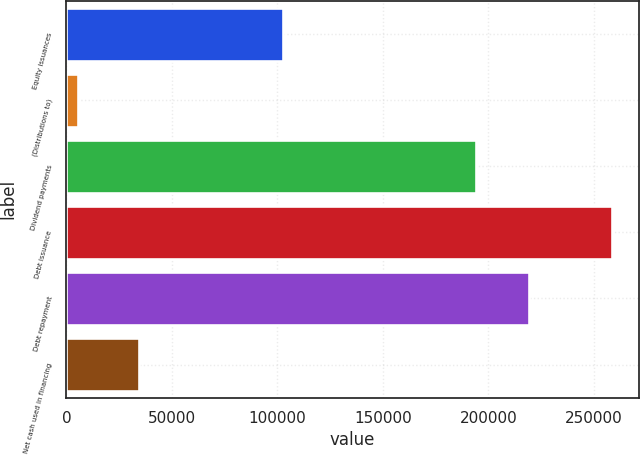Convert chart to OTSL. <chart><loc_0><loc_0><loc_500><loc_500><bar_chart><fcel>Equity issuances<fcel>(Distributions to)<fcel>Dividend payments<fcel>Debt issuance<fcel>Debt repayment<fcel>Net cash used in financing<nl><fcel>102453<fcel>5303<fcel>193962<fcel>258378<fcel>219270<fcel>34360<nl></chart> 